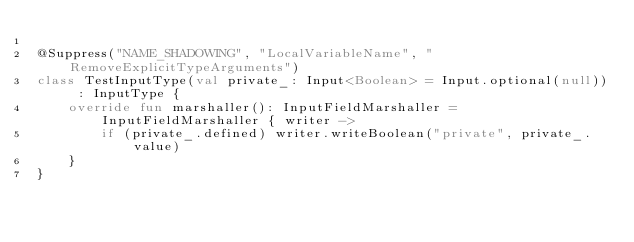Convert code to text. <code><loc_0><loc_0><loc_500><loc_500><_Kotlin_>
@Suppress("NAME_SHADOWING", "LocalVariableName", "RemoveExplicitTypeArguments")
class TestInputType(val private_: Input<Boolean> = Input.optional(null)) : InputType {
    override fun marshaller(): InputFieldMarshaller = InputFieldMarshaller { writer ->
        if (private_.defined) writer.writeBoolean("private", private_.value)
    }
}
</code> 